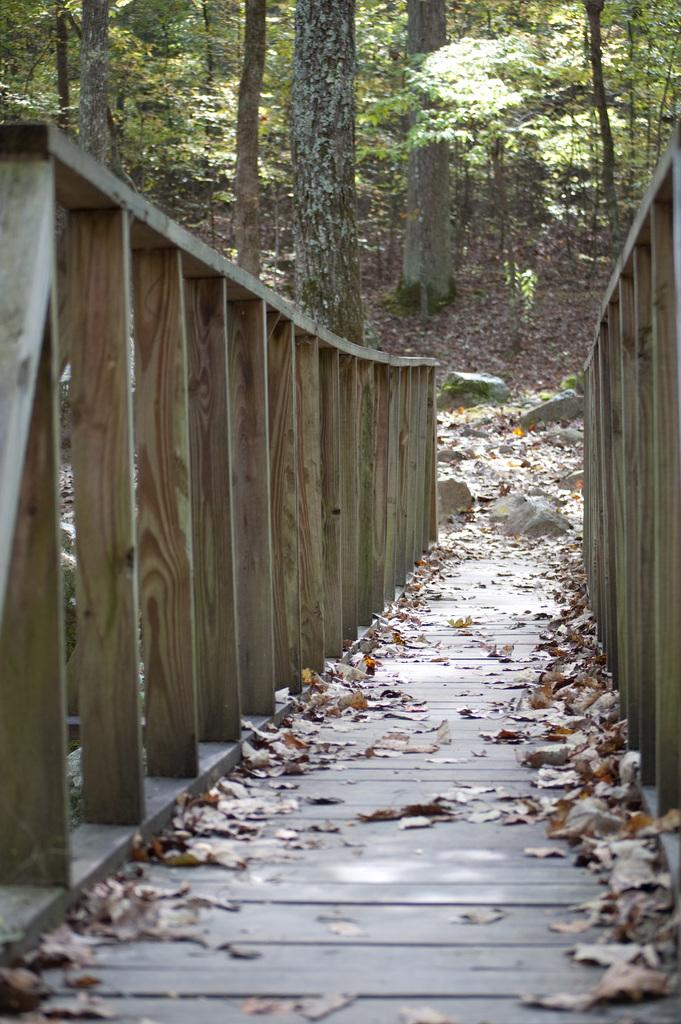What type of structure is present in the image? There is a wooden bridge in the image. What can be seen in the background of the image? Trees are visible at the top of the image. What type of notebook is being used by the person in the hospital in the image? There is no person or hospital present in the image; it only features a wooden bridge and trees. 